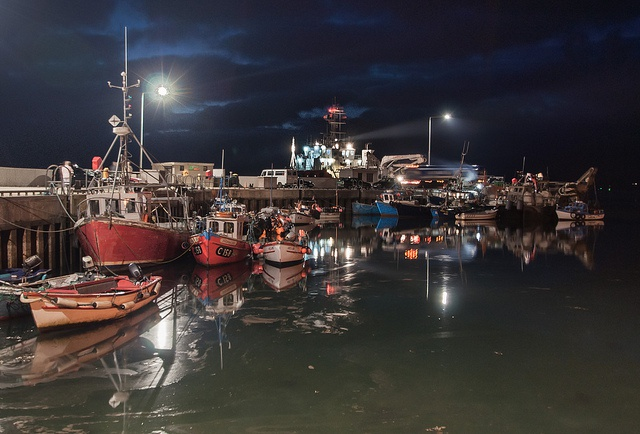Describe the objects in this image and their specific colors. I can see boat in gray, maroon, black, and brown tones, boat in gray, brown, maroon, black, and salmon tones, boat in gray, black, maroon, and brown tones, boat in gray, black, brown, darkgray, and maroon tones, and boat in gray, black, and tan tones in this image. 